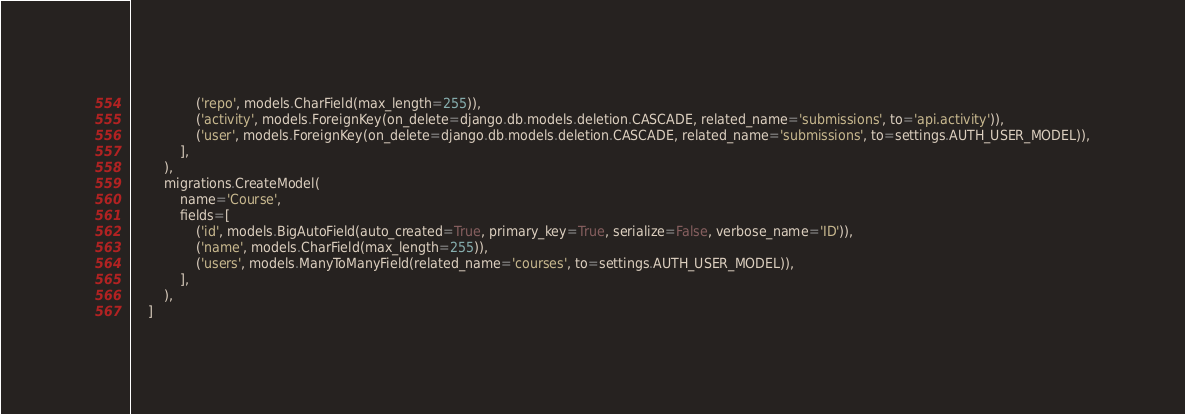Convert code to text. <code><loc_0><loc_0><loc_500><loc_500><_Python_>                ('repo', models.CharField(max_length=255)),
                ('activity', models.ForeignKey(on_delete=django.db.models.deletion.CASCADE, related_name='submissions', to='api.activity')),
                ('user', models.ForeignKey(on_delete=django.db.models.deletion.CASCADE, related_name='submissions', to=settings.AUTH_USER_MODEL)),
            ],
        ),
        migrations.CreateModel(
            name='Course',
            fields=[
                ('id', models.BigAutoField(auto_created=True, primary_key=True, serialize=False, verbose_name='ID')),
                ('name', models.CharField(max_length=255)),
                ('users', models.ManyToManyField(related_name='courses', to=settings.AUTH_USER_MODEL)),
            ],
        ),
    ]
</code> 